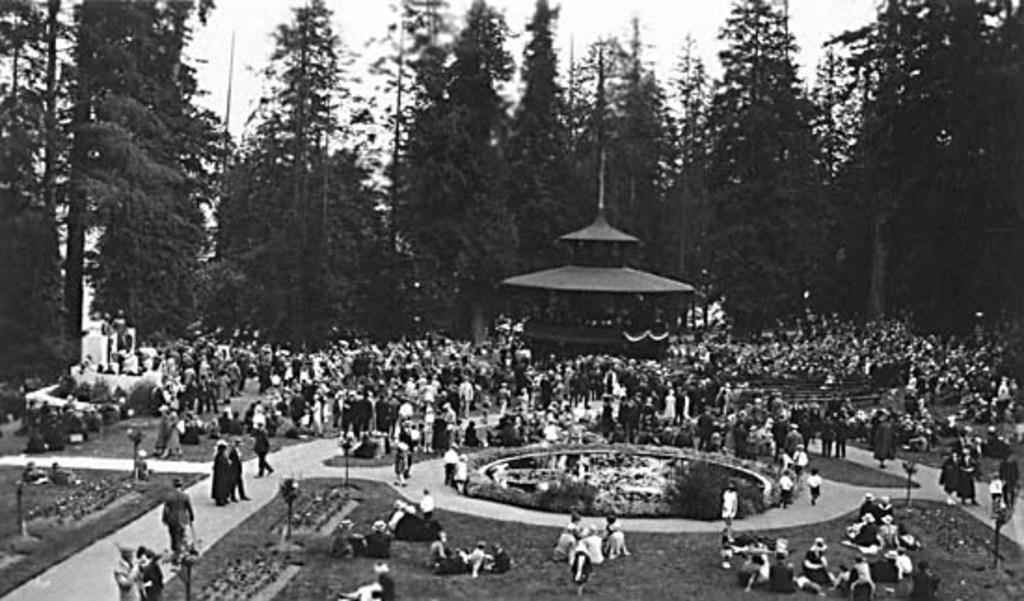Can you describe this image briefly? This is a black and white image. In this image there are so many people. At the center of the image there is a building. In the background there are trees and a sky. 